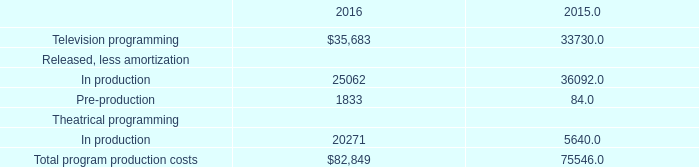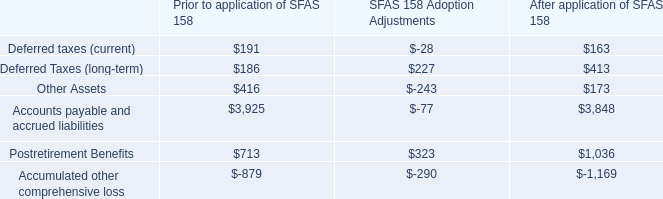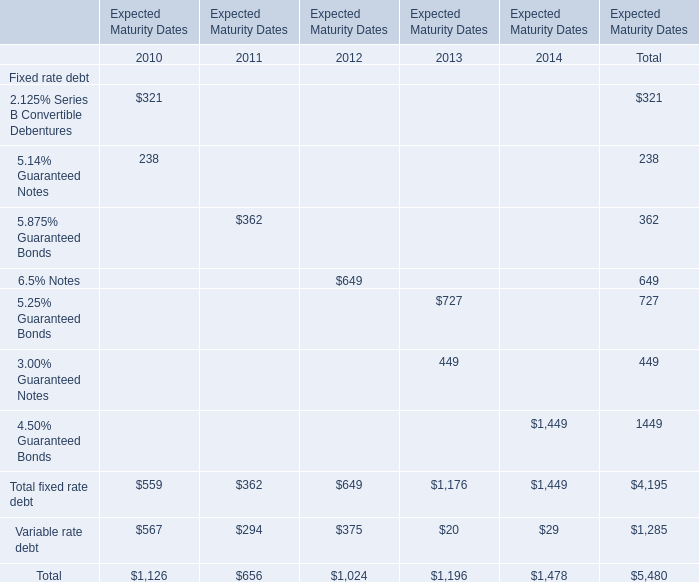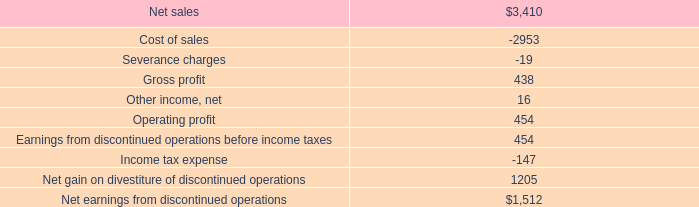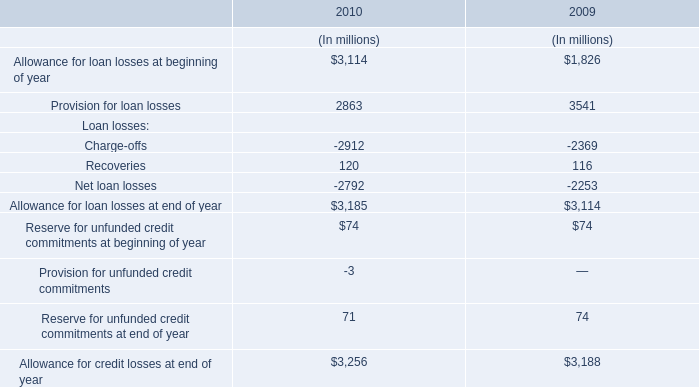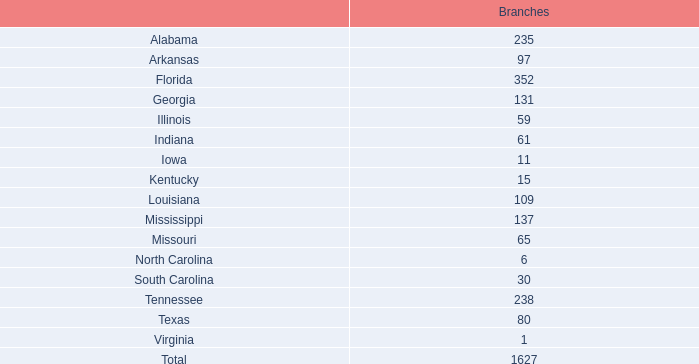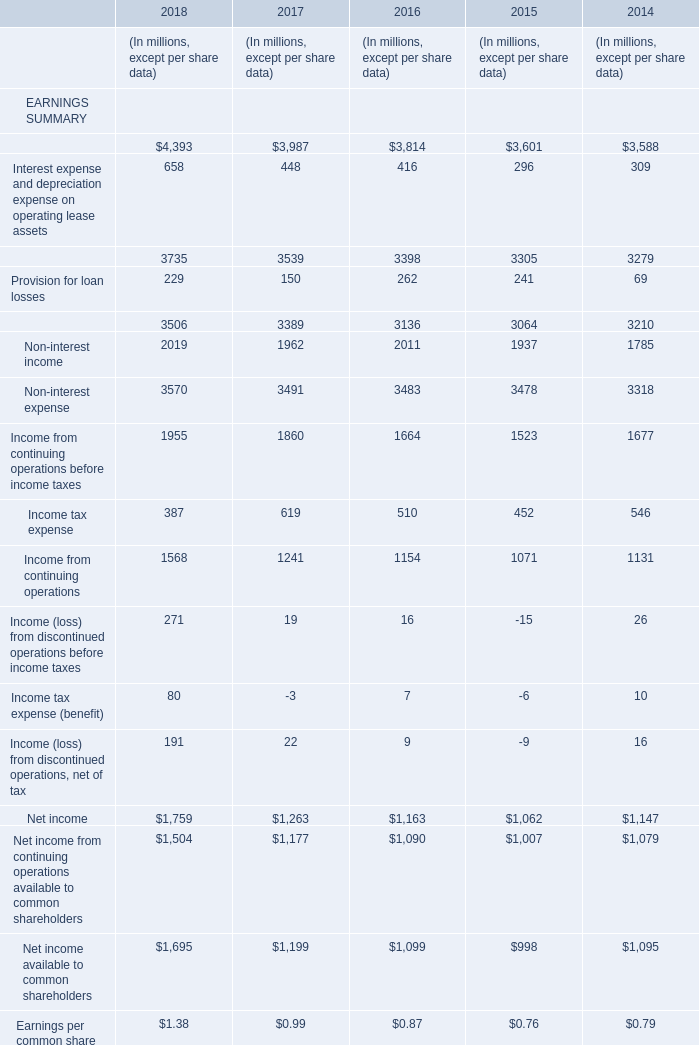What's the average of Net earnings from discontinued operations, and In production Theatrical programming of 2016 ? 
Computations: ((1512.0 + 20271.0) / 2)
Answer: 10891.5. 